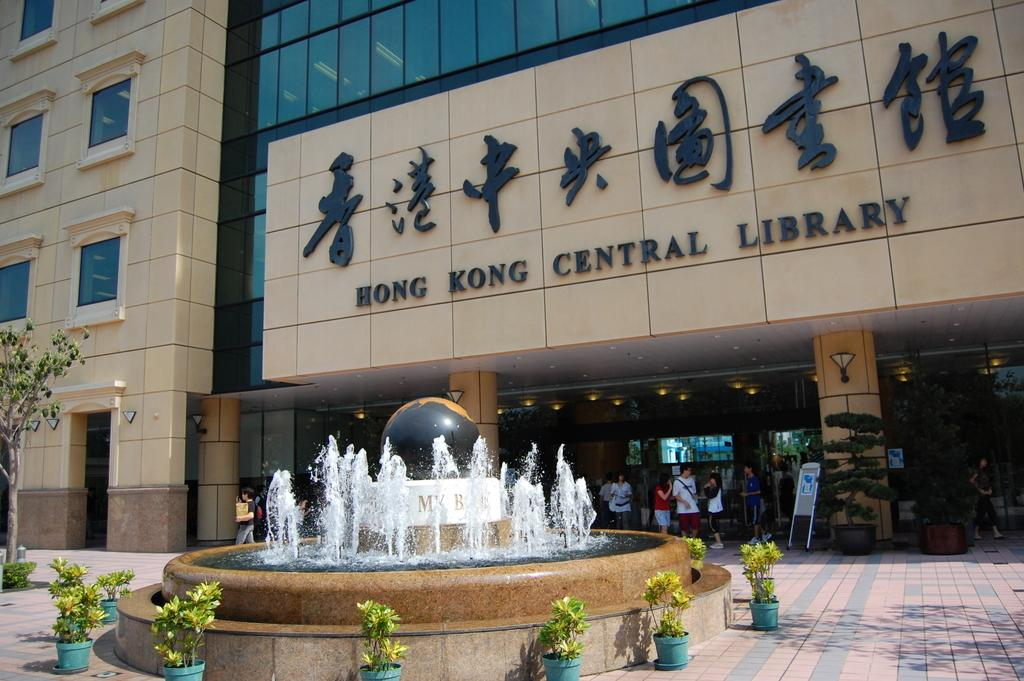<image>
Describe the image concisely. A water fountain outside the entrance to the Hong Kong Central Library. 